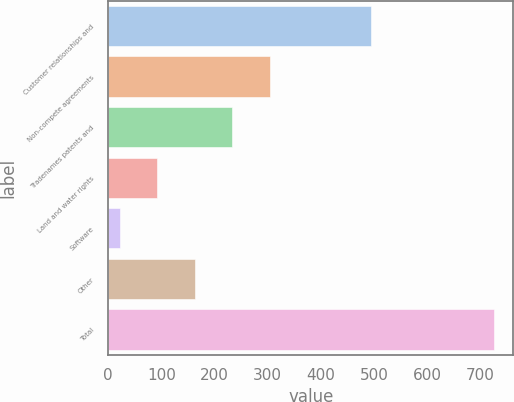<chart> <loc_0><loc_0><loc_500><loc_500><bar_chart><fcel>Customer relationships and<fcel>Non-compete agreements<fcel>Tradenames patents and<fcel>Land and water rights<fcel>Software<fcel>Other<fcel>Total<nl><fcel>495<fcel>303.6<fcel>233.2<fcel>92.4<fcel>22<fcel>162.8<fcel>726<nl></chart> 